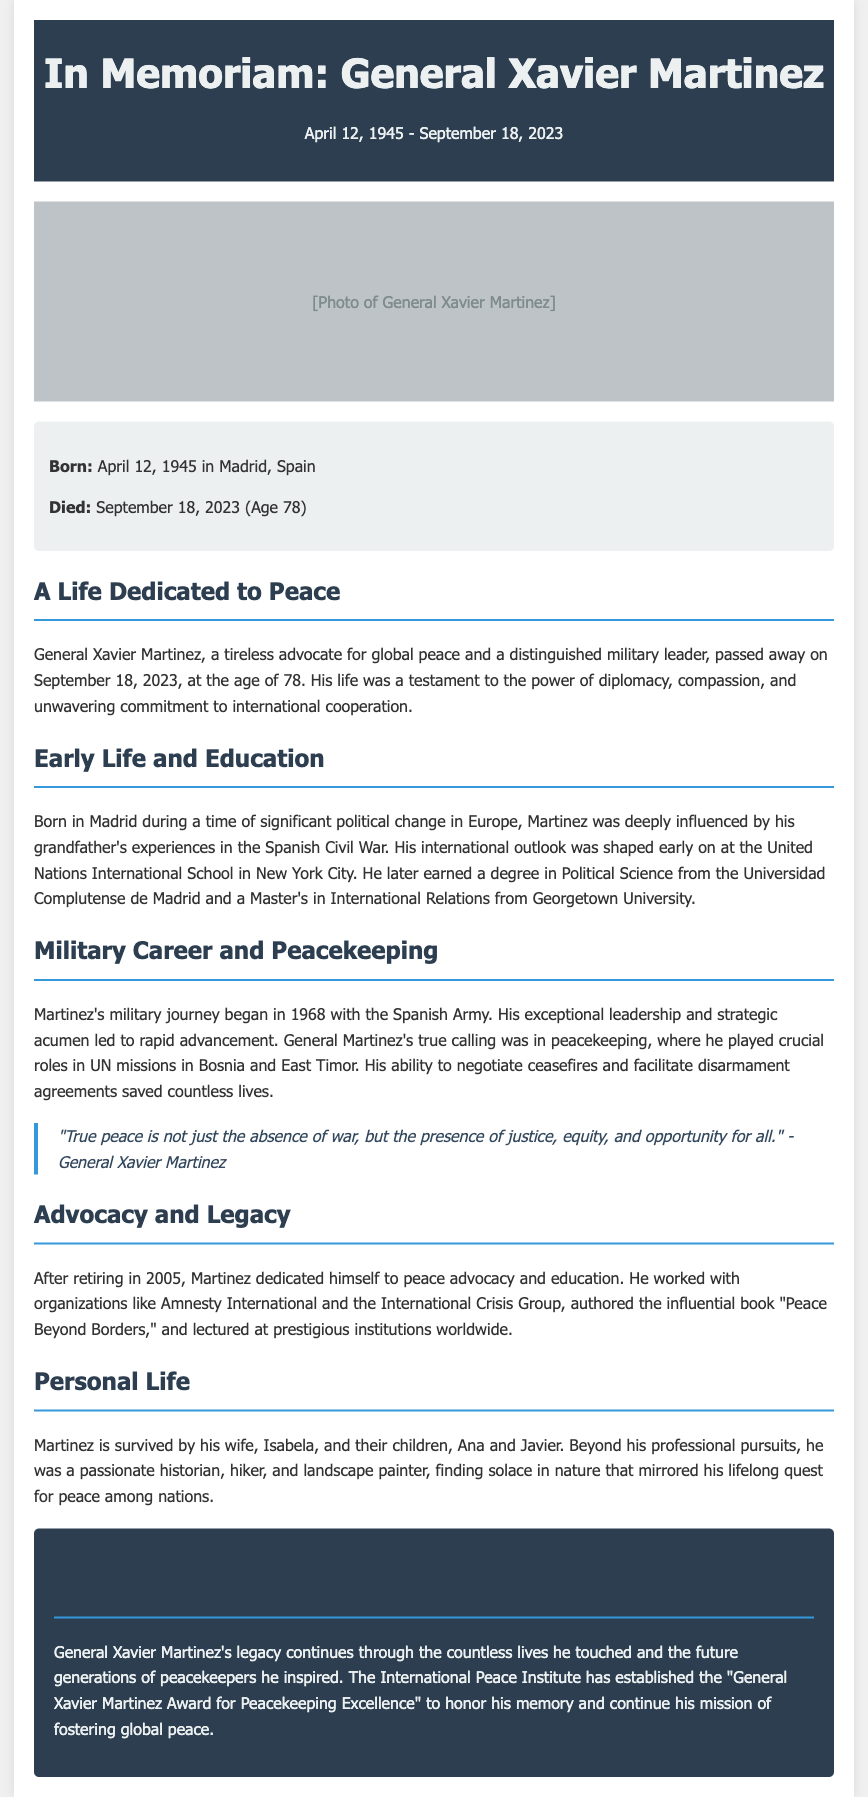what was General Xavier Martinez's date of birth? The document states that General Xavier Martinez was born on April 12, 1945.
Answer: April 12, 1945 what age was General Xavier Martinez when he died? The obituary mentions that he died at the age of 78.
Answer: 78 where did General Xavier Martinez earn his Master's degree? The document indicates that he earned a Master's in International Relations from Georgetown University.
Answer: Georgetown University what was the title of the book authored by General Martinez? It is mentioned in the document that he authored the book "Peace Beyond Borders."
Answer: Peace Beyond Borders which military branch did General Martinez begin his career in? The obituary specifies that he began his military career in the Spanish Army.
Answer: Spanish Army what is the name of the award established in General Martinez's memory? The document states that the "General Xavier Martinez Award for Peacekeeping Excellence" was established to honor his memory.
Answer: General Xavier Martinez Award for Peacekeeping Excellence how many children did General Martinez have? The biography notes that he has two children, Ana and Javier.
Answer: two what was the primary focus of General Martinez's advocacy work? The document highlights that he dedicated himself to peace advocacy and education.
Answer: peace advocacy and education what notable role did General Martinez play in UN missions? The obituary mentions that he played crucial roles in peacekeeping, specifically in negotiating ceasefires and facilitating disarmament agreements.
Answer: peacekeeping 